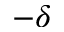<formula> <loc_0><loc_0><loc_500><loc_500>- \delta</formula> 